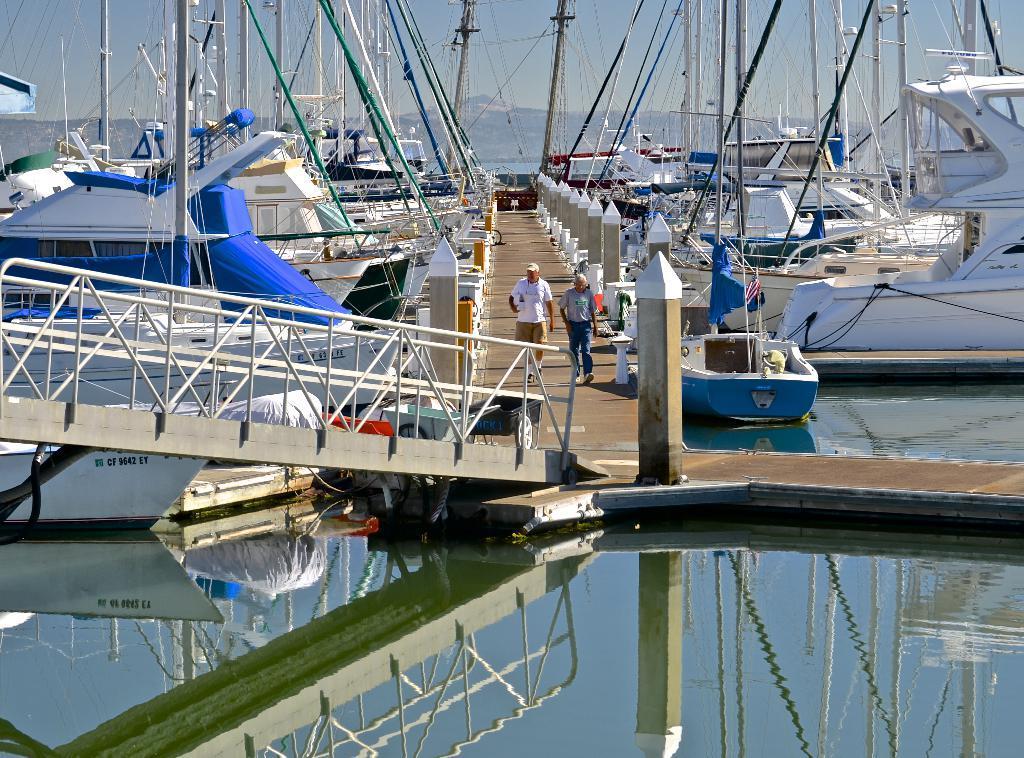Describe this image in one or two sentences. I can see two people walking. These are the boards, which are floating on the water. This looks like a bridge. These are the pillars. Here is the water flowing. In the background, I can see a hill. 